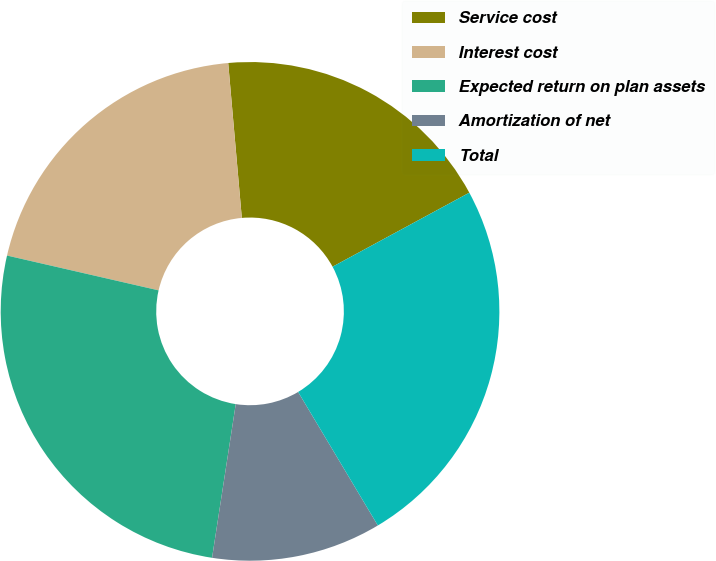Convert chart to OTSL. <chart><loc_0><loc_0><loc_500><loc_500><pie_chart><fcel>Service cost<fcel>Interest cost<fcel>Expected return on plan assets<fcel>Amortization of net<fcel>Total<nl><fcel>18.5%<fcel>20.01%<fcel>26.16%<fcel>11.0%<fcel>24.33%<nl></chart> 